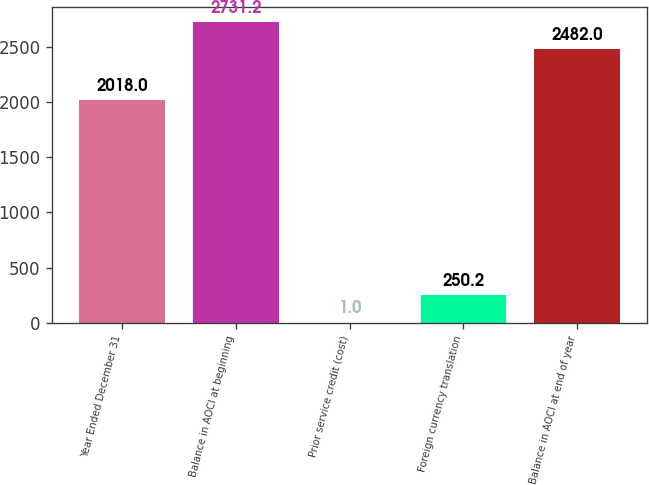Convert chart. <chart><loc_0><loc_0><loc_500><loc_500><bar_chart><fcel>Year Ended December 31<fcel>Balance in AOCI at beginning<fcel>Prior service credit (cost)<fcel>Foreign currency translation<fcel>Balance in AOCI at end of year<nl><fcel>2018<fcel>2731.2<fcel>1<fcel>250.2<fcel>2482<nl></chart> 